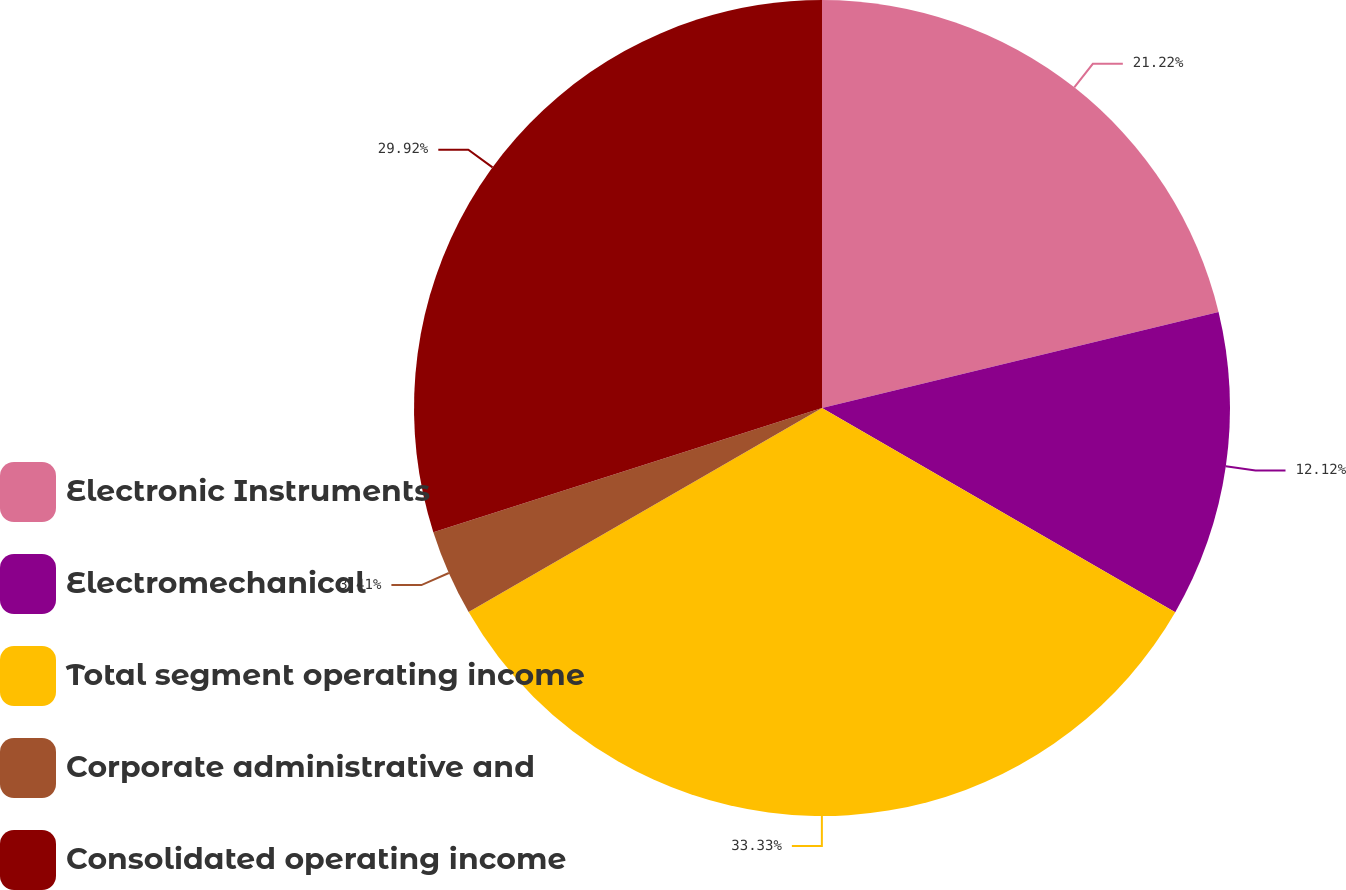Convert chart to OTSL. <chart><loc_0><loc_0><loc_500><loc_500><pie_chart><fcel>Electronic Instruments<fcel>Electromechanical<fcel>Total segment operating income<fcel>Corporate administrative and<fcel>Consolidated operating income<nl><fcel>21.22%<fcel>12.12%<fcel>33.33%<fcel>3.41%<fcel>29.92%<nl></chart> 